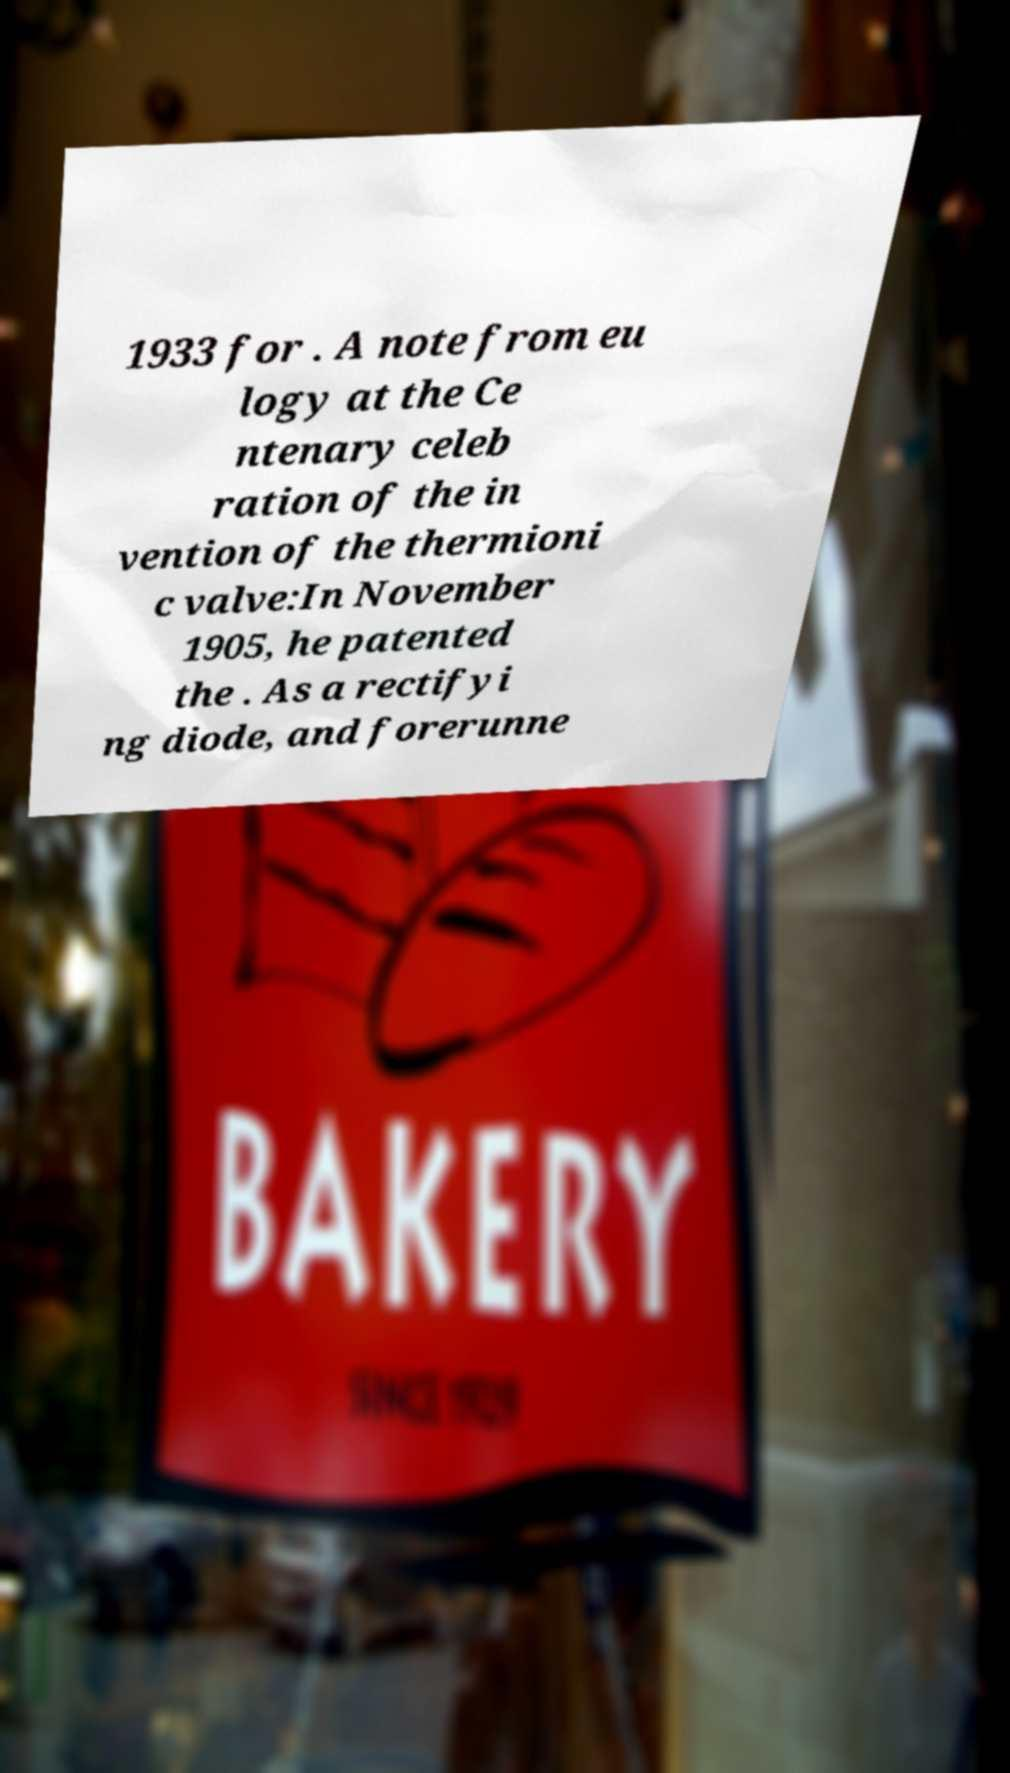For documentation purposes, I need the text within this image transcribed. Could you provide that? 1933 for . A note from eu logy at the Ce ntenary celeb ration of the in vention of the thermioni c valve:In November 1905, he patented the . As a rectifyi ng diode, and forerunne 